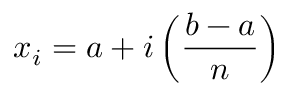Convert formula to latex. <formula><loc_0><loc_0><loc_500><loc_500>x _ { i } = a + i \left ( { \frac { b - a } { n } } \right )</formula> 